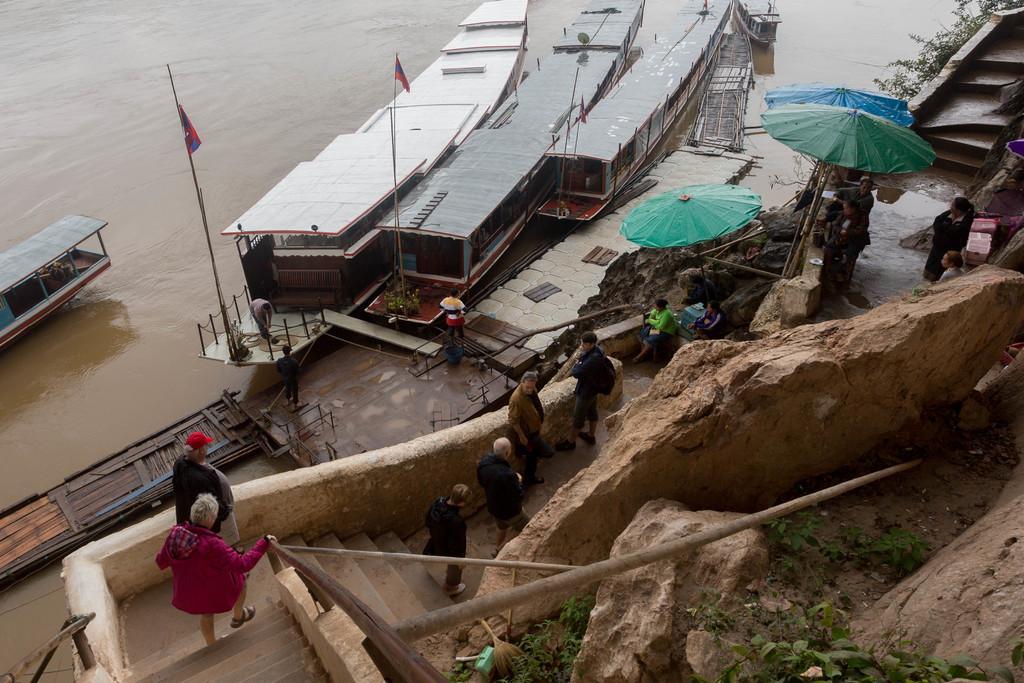Can you describe this image briefly? In this image there are boats, flags, people, steps, umbrellas, rocks, leaves and objects. 